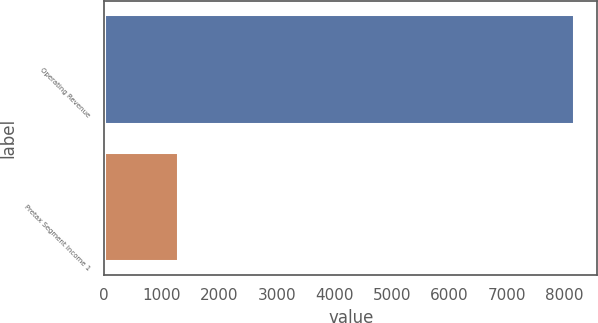Convert chart to OTSL. <chart><loc_0><loc_0><loc_500><loc_500><bar_chart><fcel>Operating Revenue<fcel>Pretax Segment Income 1<nl><fcel>8171<fcel>1278<nl></chart> 